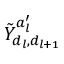Convert formula to latex. <formula><loc_0><loc_0><loc_500><loc_500>\tilde { Y } _ { d _ { l } , d _ { l + 1 } } ^ { a _ { l } ^ { \prime } }</formula> 